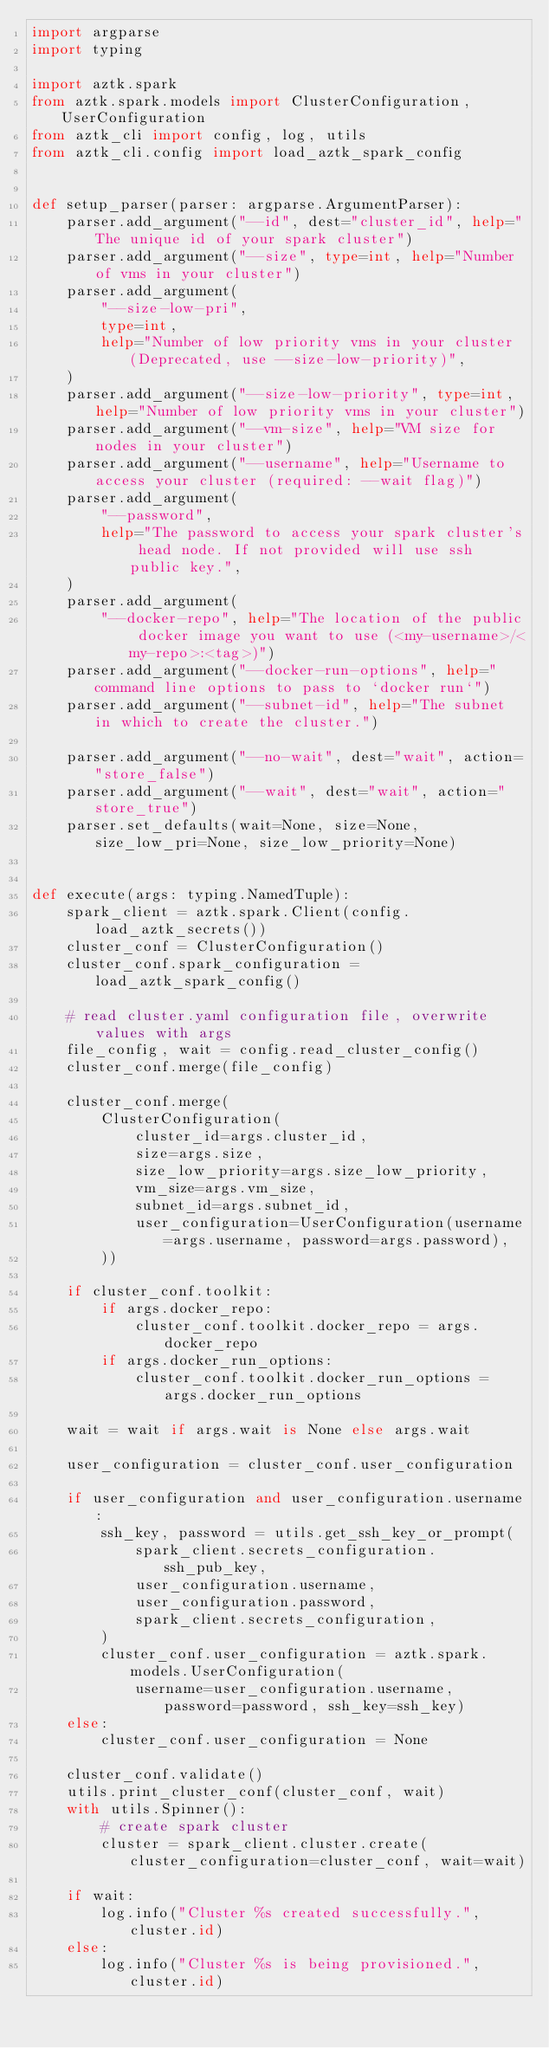Convert code to text. <code><loc_0><loc_0><loc_500><loc_500><_Python_>import argparse
import typing

import aztk.spark
from aztk.spark.models import ClusterConfiguration, UserConfiguration
from aztk_cli import config, log, utils
from aztk_cli.config import load_aztk_spark_config


def setup_parser(parser: argparse.ArgumentParser):
    parser.add_argument("--id", dest="cluster_id", help="The unique id of your spark cluster")
    parser.add_argument("--size", type=int, help="Number of vms in your cluster")
    parser.add_argument(
        "--size-low-pri",
        type=int,
        help="Number of low priority vms in your cluster (Deprecated, use --size-low-priority)",
    )
    parser.add_argument("--size-low-priority", type=int, help="Number of low priority vms in your cluster")
    parser.add_argument("--vm-size", help="VM size for nodes in your cluster")
    parser.add_argument("--username", help="Username to access your cluster (required: --wait flag)")
    parser.add_argument(
        "--password",
        help="The password to access your spark cluster's head node. If not provided will use ssh public key.",
    )
    parser.add_argument(
        "--docker-repo", help="The location of the public docker image you want to use (<my-username>/<my-repo>:<tag>)")
    parser.add_argument("--docker-run-options", help="command line options to pass to `docker run`")
    parser.add_argument("--subnet-id", help="The subnet in which to create the cluster.")

    parser.add_argument("--no-wait", dest="wait", action="store_false")
    parser.add_argument("--wait", dest="wait", action="store_true")
    parser.set_defaults(wait=None, size=None, size_low_pri=None, size_low_priority=None)


def execute(args: typing.NamedTuple):
    spark_client = aztk.spark.Client(config.load_aztk_secrets())
    cluster_conf = ClusterConfiguration()
    cluster_conf.spark_configuration = load_aztk_spark_config()

    # read cluster.yaml configuration file, overwrite values with args
    file_config, wait = config.read_cluster_config()
    cluster_conf.merge(file_config)

    cluster_conf.merge(
        ClusterConfiguration(
            cluster_id=args.cluster_id,
            size=args.size,
            size_low_priority=args.size_low_priority,
            vm_size=args.vm_size,
            subnet_id=args.subnet_id,
            user_configuration=UserConfiguration(username=args.username, password=args.password),
        ))

    if cluster_conf.toolkit:
        if args.docker_repo:
            cluster_conf.toolkit.docker_repo = args.docker_repo
        if args.docker_run_options:
            cluster_conf.toolkit.docker_run_options = args.docker_run_options

    wait = wait if args.wait is None else args.wait

    user_configuration = cluster_conf.user_configuration

    if user_configuration and user_configuration.username:
        ssh_key, password = utils.get_ssh_key_or_prompt(
            spark_client.secrets_configuration.ssh_pub_key,
            user_configuration.username,
            user_configuration.password,
            spark_client.secrets_configuration,
        )
        cluster_conf.user_configuration = aztk.spark.models.UserConfiguration(
            username=user_configuration.username, password=password, ssh_key=ssh_key)
    else:
        cluster_conf.user_configuration = None

    cluster_conf.validate()
    utils.print_cluster_conf(cluster_conf, wait)
    with utils.Spinner():
        # create spark cluster
        cluster = spark_client.cluster.create(cluster_configuration=cluster_conf, wait=wait)

    if wait:
        log.info("Cluster %s created successfully.", cluster.id)
    else:
        log.info("Cluster %s is being provisioned.", cluster.id)
</code> 